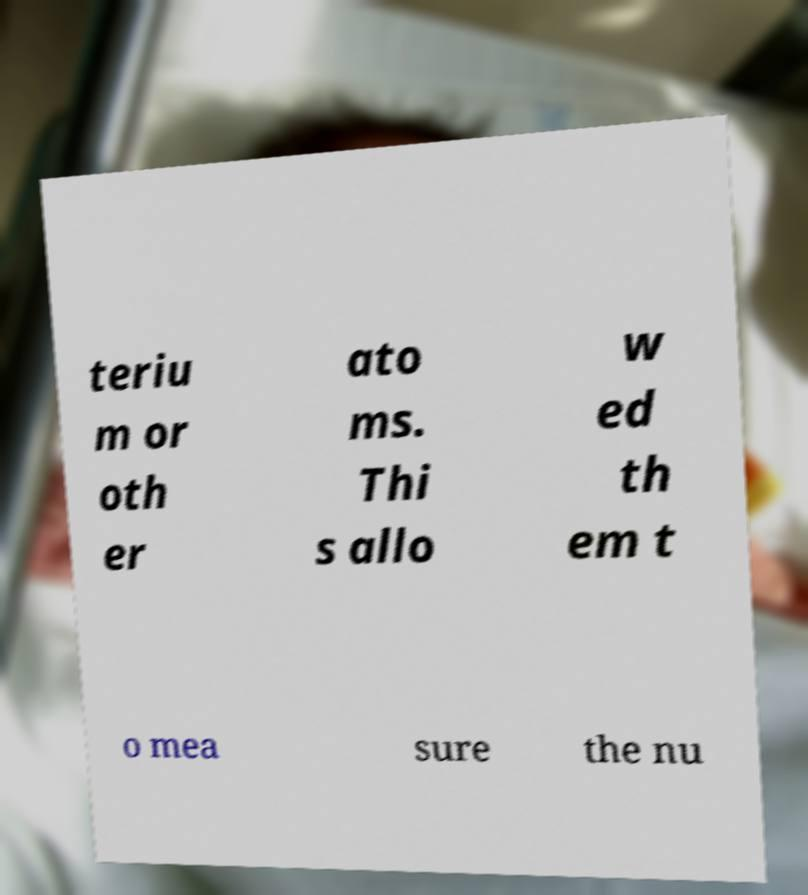Please identify and transcribe the text found in this image. teriu m or oth er ato ms. Thi s allo w ed th em t o mea sure the nu 